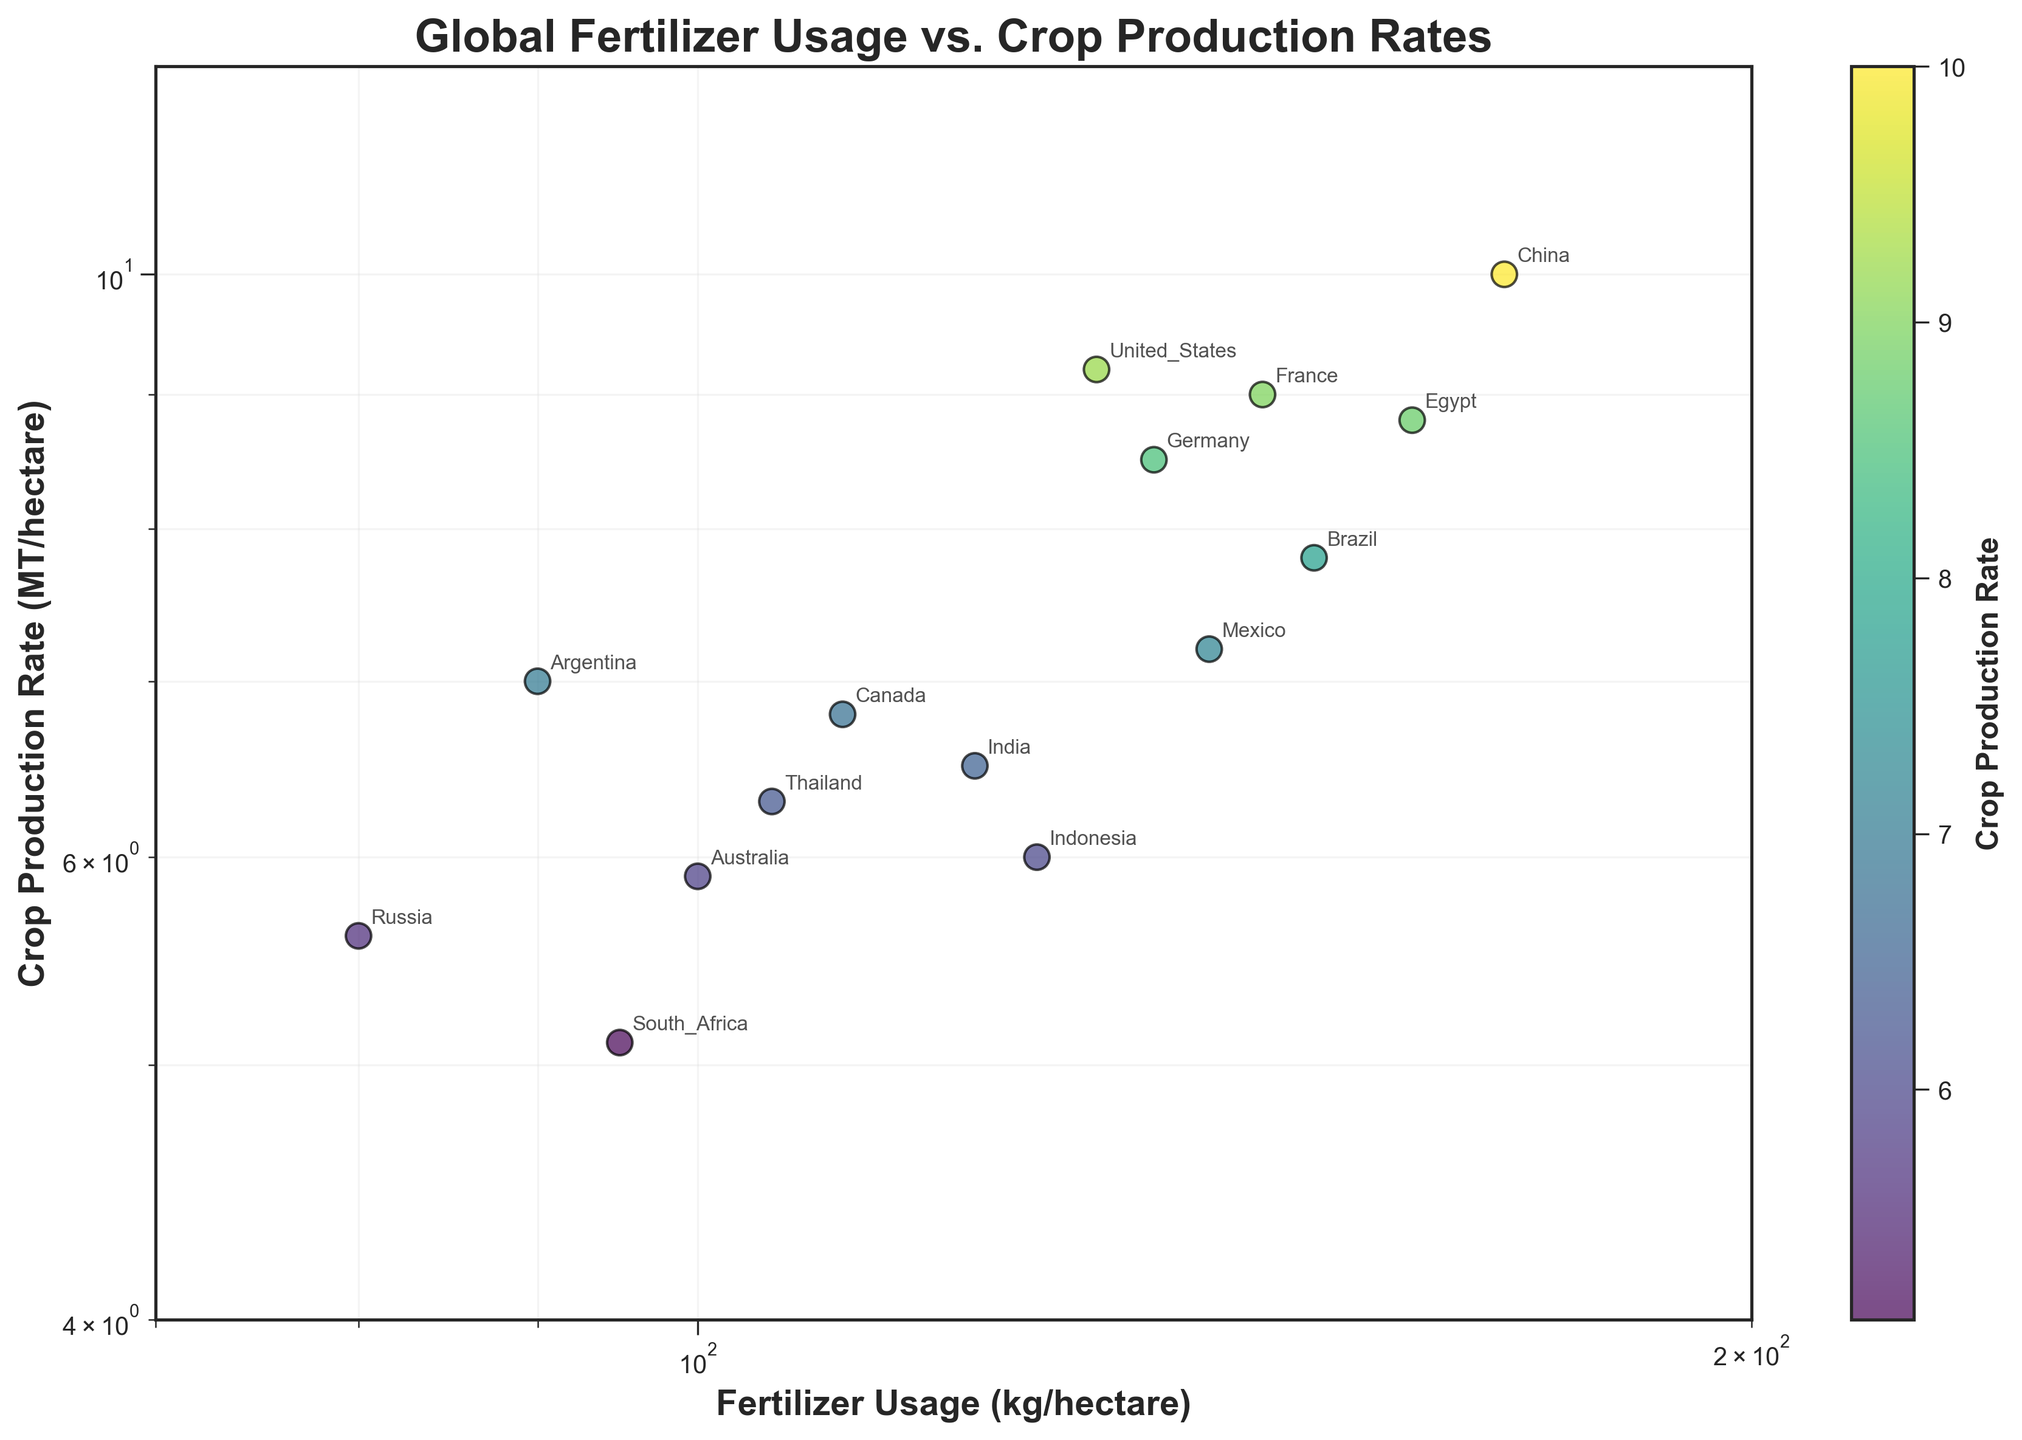Which country has the highest crop production rate? To find the country with the highest crop production rate, look for the data point with the highest y-coordinate value. In the scatter plot, China has the highest crop production rate with a value of 10.0 MT/hectare.
Answer: China What is the range of fertilizer usage shown in the figure? The x-axis represents fertilizer usage, and its range is from the minimum value to the maximum value displayed in the plot. The figure shows fertilizer usage ranging from 70 kg/hectare to 200 kg/hectare, as indicated by the x-axis limits.
Answer: 70 to 200 kg/hectare Which country uses the least amount of fertilizer? To find the country using the least amount of fertilizer, identify the data point with the lowest x-coordinate value. In the scatter plot, Russia has the least fertilizer usage at 80 kg/hectare.
Answer: Russia How many countries have a crop production rate higher than 8.0 MT/hectare? Count the number of data points with y-values greater than 8.0 on the crop production rate axis. The countries are United States, China, France, Germany, and Egypt, which totals to 5 countries.
Answer: 5 What is the crop production rate of Canada? Locate the data point labeled "Canada" and refer to its y-coordinate value to find the crop production rate. In the scatter plot, Canada's crop production rate is 6.8 MT/hectare.
Answer: 6.8 MT/hectare Which countries have a fertilizer usage between 100 and 150 kg/hectare? Identify the data points within the x-coordinate range of 100 to 150 and note the corresponding country labels. The countries within this range are Australia, Canada, Indonesia, Mexico, Thailand, France, Brazil, and India.
Answer: Australia, Canada, Indonesia, Mexico, Thailand, France, Brazil, India Is there a visible trend between fertilizer usage and crop production rate? Observe the overall distribution of the data points in the scatter plot. While there is some variation, a general trend shows that higher fertilizer usage tends to correlate with higher crop production rates, though there are exceptions.
Answer: Yes, a general trend What is the approximate crop production rate of Brazil? Locate the data point labeled "Brazil" and refer to its y-coordinate value to approximate the crop production rate. In the scatter plot, Brazil's crop production rate is approximately 7.8 MT/hectare.
Answer: 7.8 MT/hectare Which country has a higher crop production rate, Brazil or Argentina? Compare the y-coordinates of the data points for Brazil and Argentina. Brazil has a crop production rate of 7.8 MT/hectare, while Argentina has 7.0 MT/hectare.
Answer: Brazil Which country is closest in crop production rate to the global leader, China? Identify the data point with the highest crop production rate (China) and then locate the data point with a y-coordinate closest to China's 10.0 MT/hectare. The United States, with a crop production rate of 9.2 MT/hectare, is the closest.
Answer: United States 